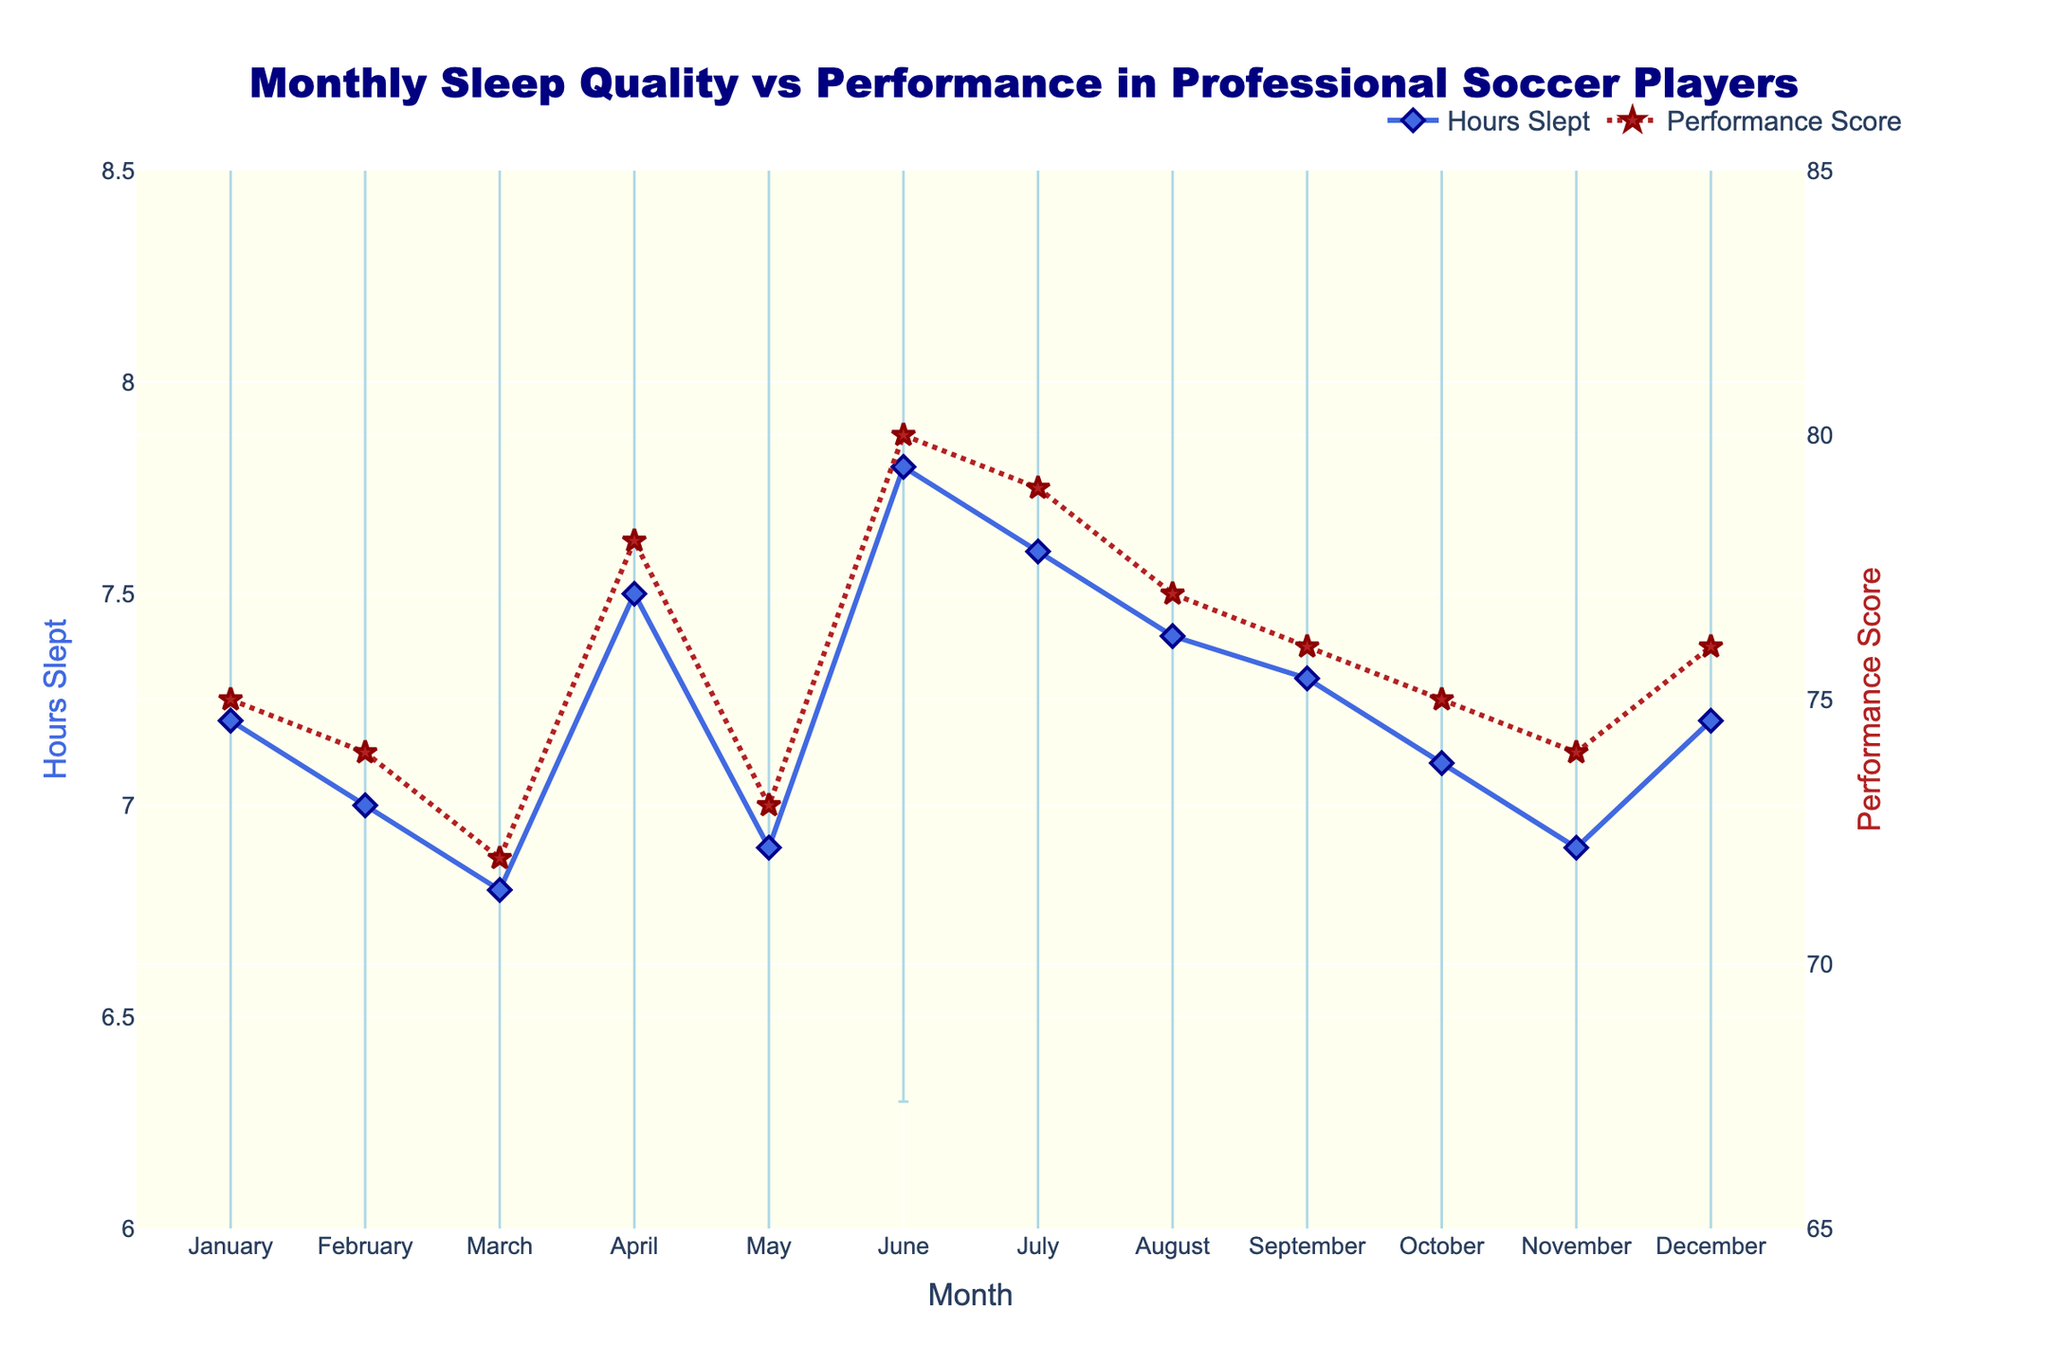Which month had the highest average hours slept? The month with the highest average hours slept is identified by locating the peak in the "Hours Slept" line plot.
Answer: June What is the performance score for the month with the lowest average hours slept? Identify the month with the lowest average hours slept from the "Hours Slept" line plot and then check the "Performance Score" for that month.
Answer: March Explain the relationship between hours slept and performance score in July. Locate July on the x-axis and observe both the average hours slept and performance score for that month. Compare their values and look for a correlation.
Answer: Hours slept: 7.6, Performance score: 79 Which months had a performance score greater than 75? Identify the months where the "Performance Score" line plot is above 75 from the y-axis on the right.
Answer: April, June, July, August, December What is the average performance score for the months where the average hours slept was less than 7 hours? Identify the months where "Hours Slept" is less than 7 from the respective line plot, then take the performance scores for those months and calculate their average. Steps: (1) Identify months (March, May, November), (2) Sum of scores: 72 + 73 + 74 = 219, (3) Average = 219 / 3.
Answer: 73 Compare the error bars for April and October and determine which month had a higher uncertainty in hours slept. Examine the length of the error bars for April and October in the "Hours Slept" line plot.
Answer: October In what month(s) does the difference between hours slept and performance score reach the maximum? Calculate the difference between hours slept and performance score for each month, then identify the maximum difference.
Answer: June How much did the performance score change from January to February? Find the difference in performance scores between January and February by subtracting the performance score of January from that of February. Steps: (1) January: 75, (2) February: 74, (3) Difference: 74 - 75.
Answer: -1 During which month did the average hours slept show the least variability (smallest error bar)? Identify the month with the shortest error bar on the "Hours Slept" line plot.
Answer: June If April's error in hours slept changed to 3, how would it compare to the error in November? First, recognize that April's original error bar is 2. Hypothetically change it to 3 and compare it to November's error, which is 2.5.
Answer: April would have higher variability 